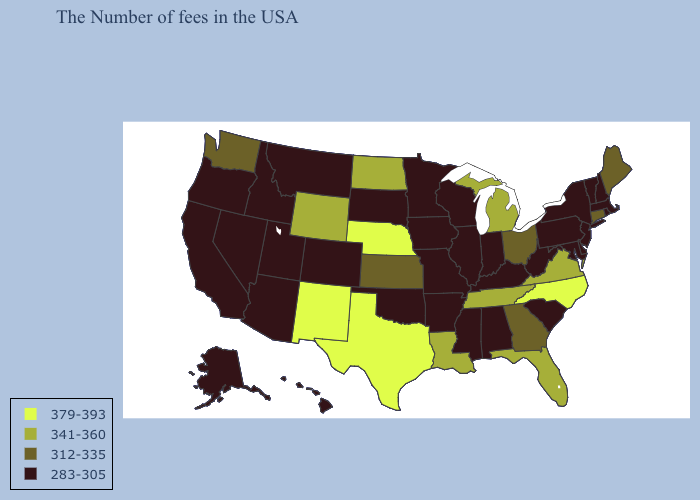What is the value of Alaska?
Write a very short answer. 283-305. What is the highest value in the Northeast ?
Quick response, please. 312-335. What is the value of Idaho?
Quick response, please. 283-305. What is the value of Florida?
Keep it brief. 341-360. What is the highest value in the Northeast ?
Short answer required. 312-335. Name the states that have a value in the range 379-393?
Write a very short answer. North Carolina, Nebraska, Texas, New Mexico. Name the states that have a value in the range 312-335?
Quick response, please. Maine, Connecticut, Ohio, Georgia, Kansas, Washington. What is the value of Hawaii?
Write a very short answer. 283-305. Among the states that border Mississippi , which have the highest value?
Short answer required. Tennessee, Louisiana. Does North Carolina have a higher value than Delaware?
Be succinct. Yes. What is the highest value in states that border Arizona?
Give a very brief answer. 379-393. Name the states that have a value in the range 379-393?
Concise answer only. North Carolina, Nebraska, Texas, New Mexico. What is the highest value in states that border New Hampshire?
Quick response, please. 312-335. What is the value of Texas?
Answer briefly. 379-393. Name the states that have a value in the range 312-335?
Keep it brief. Maine, Connecticut, Ohio, Georgia, Kansas, Washington. 